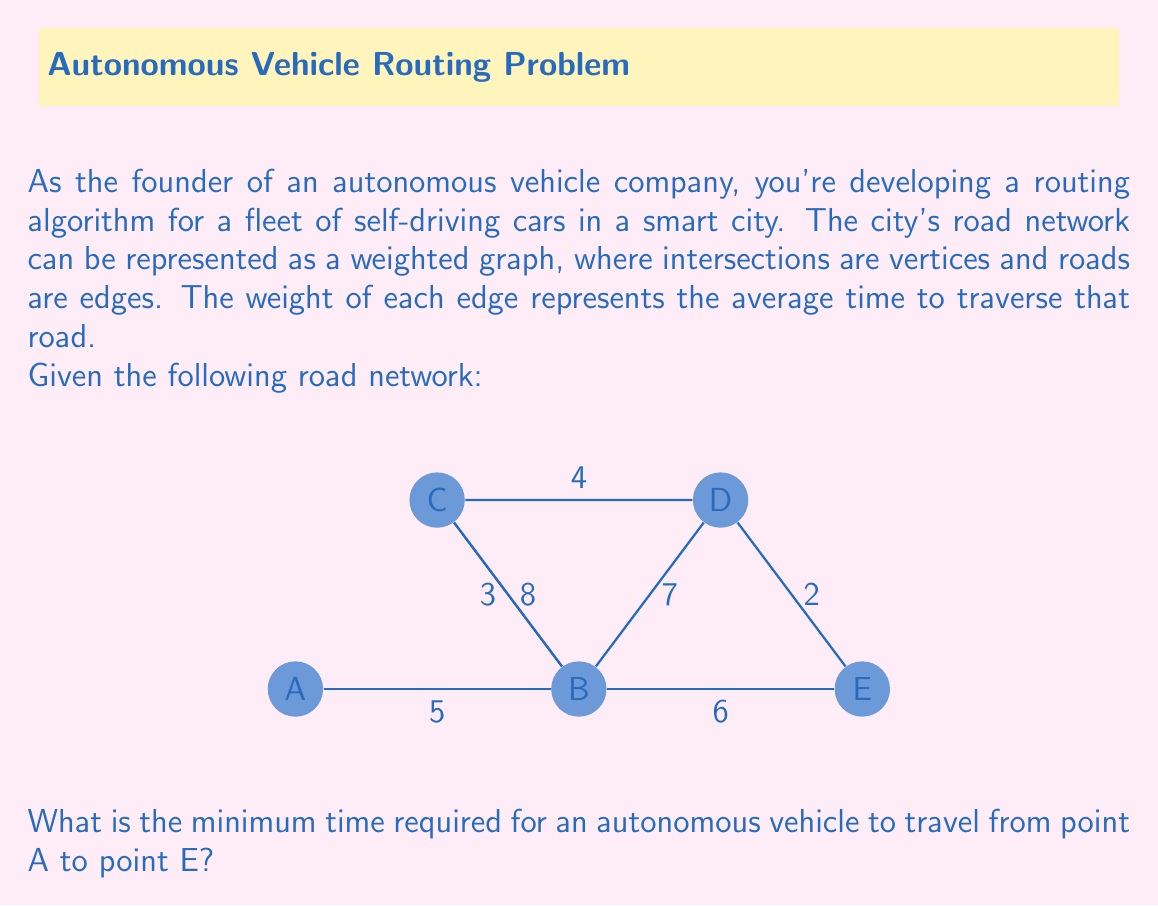Could you help me with this problem? To solve this problem, we need to find the shortest path from A to E in the given weighted graph. We can use Dijkstra's algorithm, which is commonly used in routing applications for autonomous vehicles.

Let's apply Dijkstra's algorithm step by step:

1) Initialize:
   - Distance to A: 0
   - Distance to all other vertices: ∞ (infinity)
   - Set of unvisited nodes: {A, B, C, D, E}

2) From A, we can only go to B with a distance of 5:
   - Distance to B: 5
   - Unvisited: {B, C, D, E}

3) From B, we can go to C, D, or E:
   - Distance to C: min(∞, 5 + 3) = 8
   - Distance to D: min(∞, 5 + 7) = 12
   - Distance to E: min(∞, 5 + 6) = 11
   - Unvisited: {C, D, E}

4) From C, we can update the distance to D:
   - Distance to D: min(12, 8 + 4) = 12
   - Unvisited: {D, E}

5) From D, we can update the distance to E:
   - Distance to E: min(11, 12 + 2) = 11
   - Unvisited: {E}

6) E is the destination, and we've found the shortest path.

The shortest path is A -> B -> E, with a total distance (time) of 11 units.

This algorithm demonstrates how graph theory is applied in autonomous vehicle routing, finding the optimal path in a complex road network.
Answer: 11 time units 